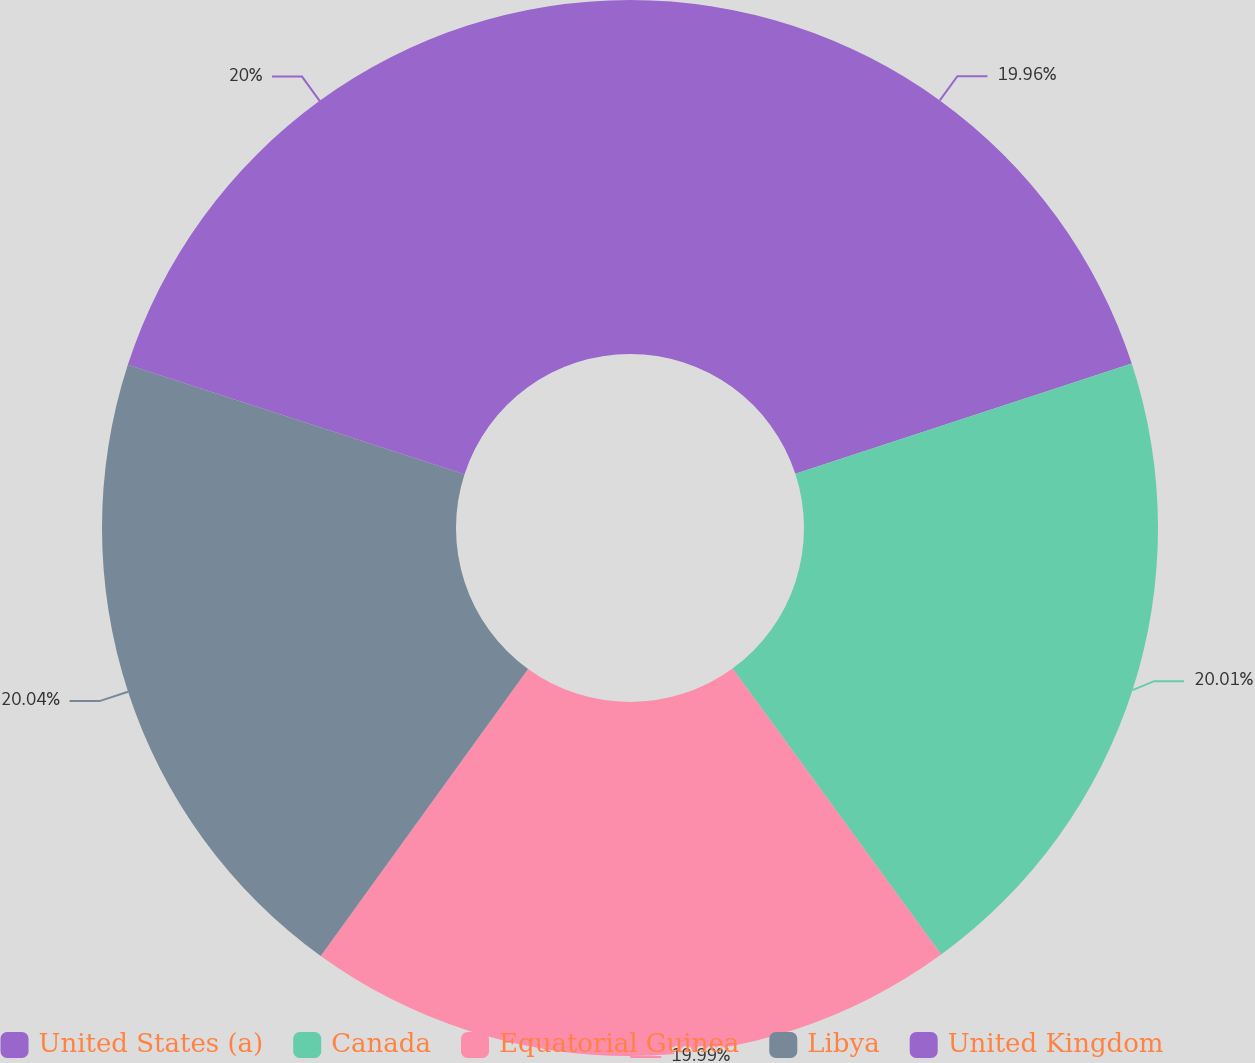Convert chart to OTSL. <chart><loc_0><loc_0><loc_500><loc_500><pie_chart><fcel>United States (a)<fcel>Canada<fcel>Equatorial Guinea<fcel>Libya<fcel>United Kingdom<nl><fcel>19.96%<fcel>20.01%<fcel>19.99%<fcel>20.04%<fcel>20.0%<nl></chart> 